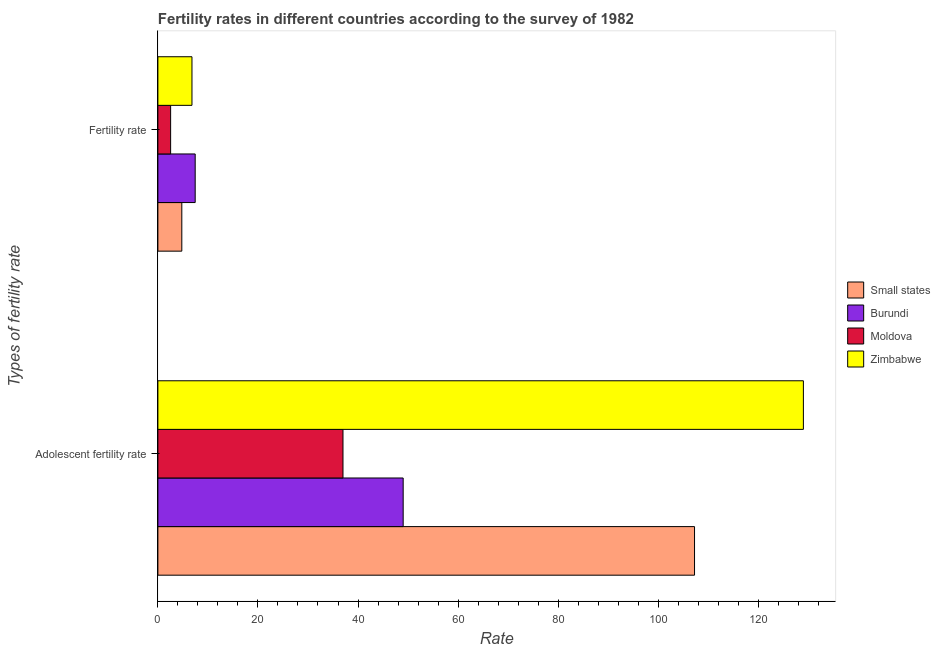Are the number of bars per tick equal to the number of legend labels?
Provide a succinct answer. Yes. Are the number of bars on each tick of the Y-axis equal?
Your answer should be compact. Yes. How many bars are there on the 2nd tick from the top?
Provide a short and direct response. 4. How many bars are there on the 2nd tick from the bottom?
Keep it short and to the point. 4. What is the label of the 1st group of bars from the top?
Keep it short and to the point. Fertility rate. What is the fertility rate in Zimbabwe?
Provide a short and direct response. 6.81. Across all countries, what is the maximum fertility rate?
Your response must be concise. 7.45. Across all countries, what is the minimum fertility rate?
Offer a terse response. 2.55. In which country was the adolescent fertility rate maximum?
Your answer should be very brief. Zimbabwe. In which country was the adolescent fertility rate minimum?
Provide a succinct answer. Moldova. What is the total adolescent fertility rate in the graph?
Offer a terse response. 322.3. What is the difference between the adolescent fertility rate in Moldova and that in Zimbabwe?
Your answer should be very brief. -92.02. What is the difference between the adolescent fertility rate in Burundi and the fertility rate in Zimbabwe?
Give a very brief answer. 42.21. What is the average fertility rate per country?
Your answer should be very brief. 5.4. What is the difference between the fertility rate and adolescent fertility rate in Zimbabwe?
Keep it short and to the point. -122.21. What is the ratio of the fertility rate in Moldova to that in Burundi?
Keep it short and to the point. 0.34. In how many countries, is the adolescent fertility rate greater than the average adolescent fertility rate taken over all countries?
Your answer should be compact. 2. What does the 2nd bar from the top in Adolescent fertility rate represents?
Keep it short and to the point. Moldova. What does the 4th bar from the bottom in Adolescent fertility rate represents?
Make the answer very short. Zimbabwe. How many bars are there?
Give a very brief answer. 8. Are all the bars in the graph horizontal?
Give a very brief answer. Yes. How many countries are there in the graph?
Ensure brevity in your answer.  4. Does the graph contain grids?
Your answer should be compact. No. Where does the legend appear in the graph?
Ensure brevity in your answer.  Center right. How many legend labels are there?
Offer a terse response. 4. How are the legend labels stacked?
Your response must be concise. Vertical. What is the title of the graph?
Keep it short and to the point. Fertility rates in different countries according to the survey of 1982. What is the label or title of the X-axis?
Your response must be concise. Rate. What is the label or title of the Y-axis?
Give a very brief answer. Types of fertility rate. What is the Rate in Small states in Adolescent fertility rate?
Offer a very short reply. 107.26. What is the Rate of Burundi in Adolescent fertility rate?
Keep it short and to the point. 49.02. What is the Rate of Moldova in Adolescent fertility rate?
Your answer should be very brief. 37. What is the Rate in Zimbabwe in Adolescent fertility rate?
Offer a very short reply. 129.02. What is the Rate of Small states in Fertility rate?
Make the answer very short. 4.78. What is the Rate in Burundi in Fertility rate?
Provide a short and direct response. 7.45. What is the Rate of Moldova in Fertility rate?
Keep it short and to the point. 2.55. What is the Rate of Zimbabwe in Fertility rate?
Offer a very short reply. 6.81. Across all Types of fertility rate, what is the maximum Rate of Small states?
Your answer should be very brief. 107.26. Across all Types of fertility rate, what is the maximum Rate in Burundi?
Your response must be concise. 49.02. Across all Types of fertility rate, what is the maximum Rate in Moldova?
Ensure brevity in your answer.  37. Across all Types of fertility rate, what is the maximum Rate of Zimbabwe?
Keep it short and to the point. 129.02. Across all Types of fertility rate, what is the minimum Rate in Small states?
Give a very brief answer. 4.78. Across all Types of fertility rate, what is the minimum Rate of Burundi?
Give a very brief answer. 7.45. Across all Types of fertility rate, what is the minimum Rate in Moldova?
Offer a very short reply. 2.55. Across all Types of fertility rate, what is the minimum Rate of Zimbabwe?
Offer a very short reply. 6.81. What is the total Rate in Small states in the graph?
Your response must be concise. 112.04. What is the total Rate of Burundi in the graph?
Provide a succinct answer. 56.48. What is the total Rate in Moldova in the graph?
Your answer should be compact. 39.54. What is the total Rate of Zimbabwe in the graph?
Your answer should be compact. 135.83. What is the difference between the Rate of Small states in Adolescent fertility rate and that in Fertility rate?
Provide a short and direct response. 102.48. What is the difference between the Rate in Burundi in Adolescent fertility rate and that in Fertility rate?
Offer a very short reply. 41.57. What is the difference between the Rate of Moldova in Adolescent fertility rate and that in Fertility rate?
Your answer should be very brief. 34.45. What is the difference between the Rate in Zimbabwe in Adolescent fertility rate and that in Fertility rate?
Keep it short and to the point. 122.21. What is the difference between the Rate in Small states in Adolescent fertility rate and the Rate in Burundi in Fertility rate?
Offer a terse response. 99.8. What is the difference between the Rate in Small states in Adolescent fertility rate and the Rate in Moldova in Fertility rate?
Offer a terse response. 104.71. What is the difference between the Rate of Small states in Adolescent fertility rate and the Rate of Zimbabwe in Fertility rate?
Ensure brevity in your answer.  100.45. What is the difference between the Rate in Burundi in Adolescent fertility rate and the Rate in Moldova in Fertility rate?
Make the answer very short. 46.48. What is the difference between the Rate in Burundi in Adolescent fertility rate and the Rate in Zimbabwe in Fertility rate?
Your answer should be compact. 42.21. What is the difference between the Rate of Moldova in Adolescent fertility rate and the Rate of Zimbabwe in Fertility rate?
Give a very brief answer. 30.18. What is the average Rate in Small states per Types of fertility rate?
Offer a terse response. 56.02. What is the average Rate of Burundi per Types of fertility rate?
Make the answer very short. 28.24. What is the average Rate in Moldova per Types of fertility rate?
Offer a terse response. 19.77. What is the average Rate in Zimbabwe per Types of fertility rate?
Provide a succinct answer. 67.91. What is the difference between the Rate in Small states and Rate in Burundi in Adolescent fertility rate?
Your answer should be compact. 58.23. What is the difference between the Rate of Small states and Rate of Moldova in Adolescent fertility rate?
Give a very brief answer. 70.26. What is the difference between the Rate of Small states and Rate of Zimbabwe in Adolescent fertility rate?
Provide a succinct answer. -21.76. What is the difference between the Rate of Burundi and Rate of Moldova in Adolescent fertility rate?
Give a very brief answer. 12.03. What is the difference between the Rate in Burundi and Rate in Zimbabwe in Adolescent fertility rate?
Give a very brief answer. -79.99. What is the difference between the Rate in Moldova and Rate in Zimbabwe in Adolescent fertility rate?
Provide a short and direct response. -92.02. What is the difference between the Rate in Small states and Rate in Burundi in Fertility rate?
Give a very brief answer. -2.67. What is the difference between the Rate of Small states and Rate of Moldova in Fertility rate?
Offer a very short reply. 2.24. What is the difference between the Rate of Small states and Rate of Zimbabwe in Fertility rate?
Provide a succinct answer. -2.03. What is the difference between the Rate in Burundi and Rate in Moldova in Fertility rate?
Provide a succinct answer. 4.91. What is the difference between the Rate in Burundi and Rate in Zimbabwe in Fertility rate?
Ensure brevity in your answer.  0.64. What is the difference between the Rate in Moldova and Rate in Zimbabwe in Fertility rate?
Your answer should be compact. -4.26. What is the ratio of the Rate in Small states in Adolescent fertility rate to that in Fertility rate?
Ensure brevity in your answer.  22.43. What is the ratio of the Rate of Burundi in Adolescent fertility rate to that in Fertility rate?
Make the answer very short. 6.58. What is the ratio of the Rate of Moldova in Adolescent fertility rate to that in Fertility rate?
Provide a succinct answer. 14.53. What is the ratio of the Rate in Zimbabwe in Adolescent fertility rate to that in Fertility rate?
Give a very brief answer. 18.94. What is the difference between the highest and the second highest Rate in Small states?
Give a very brief answer. 102.48. What is the difference between the highest and the second highest Rate of Burundi?
Your response must be concise. 41.57. What is the difference between the highest and the second highest Rate of Moldova?
Offer a very short reply. 34.45. What is the difference between the highest and the second highest Rate of Zimbabwe?
Keep it short and to the point. 122.21. What is the difference between the highest and the lowest Rate of Small states?
Provide a succinct answer. 102.48. What is the difference between the highest and the lowest Rate in Burundi?
Your response must be concise. 41.57. What is the difference between the highest and the lowest Rate in Moldova?
Provide a succinct answer. 34.45. What is the difference between the highest and the lowest Rate of Zimbabwe?
Offer a very short reply. 122.21. 